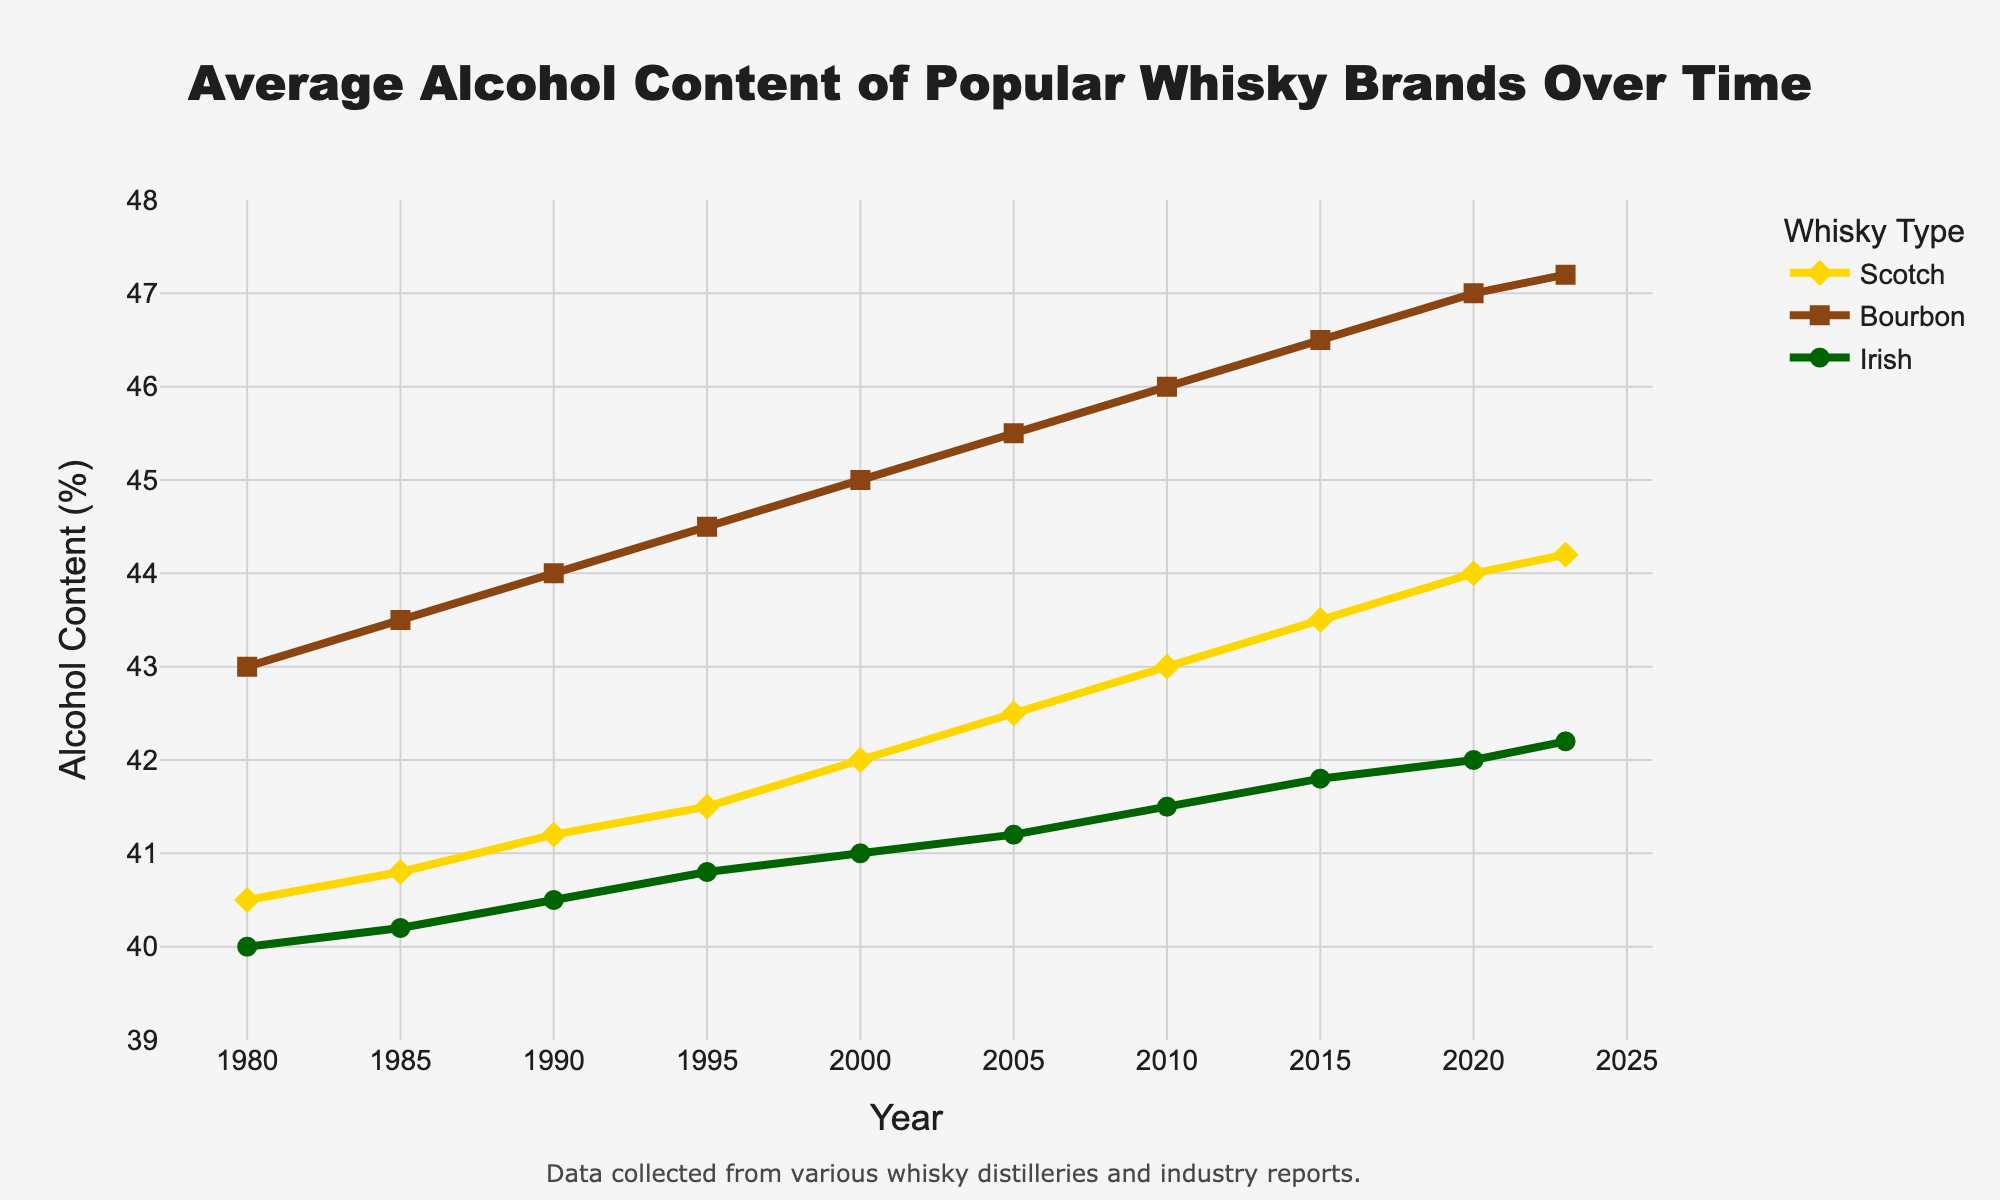What's the overall trend in the average alcohol content of Scotch from 1980 to 2023? The line for Scotch starts from 40.5% in 1980 and steadily increases to 44.2% in 2023. Therefore, the data shows a consistent upward trend in the average alcohol content of Scotch over the years.
Answer: Upward trend Between which years did Bourbon see the largest increase in average alcohol content? By visually comparing the slope of the Bourbon line, the steepest part appears between 1980 (43.0%) and 2023 (47.2%). However, for a specific interval with the steepest rise, examine the five-year intervals; the largest jump is observed between 1980-1985 (0.5%) and 1985-1990 (0.5%), consistently incrementing.
Answer: 1980 to 2023 Which whisky type had the lowest average alcohol content in 2023? At the year 2023 on the x-axis, the Irish whisky line is positioned at 42.2%, which is lower than Scotch (44.2%) and Bourbon (47.2%).
Answer: Irish What is the difference in average alcohol content between Scotch and Bourbon in 2020? In 2020, the average alcohol content for Scotch is 44.0% and for Bourbon is 47.0%. The difference between them is 47.0% - 44.0% = 3.0%.
Answer: 3.0% Which whisky type showed the least variation in the average alcohol content over the years? By visually comparing the range of the lines, the Irish whisky line is relatively flatter, starting at 40.0% in 1980 and gradually increasing to 42.2% in 2023, indicating the least variation compared to Scotch and Bourbon.
Answer: Irish How does the average alcohol content of Scotch in 1980 compare to that in 2023? The average alcohol content of Scotch in 1980 is 40.5%, while in 2023, it is 44.2%. By comparing these values, the content has increased by 44.2% - 40.5% = 3.7%.
Answer: 3.7% increase What is the average alcohol content across all whisky types in the year 2000? For 2000, Scotch is 42.0%, Bourbon is 45.0%, and Irish is 41.0%. The average alcohol content can be calculated as (42.0 + 45.0 + 41.0) / 3 = 42.67%.
Answer: 42.67% Which whisky type had the highest average alcohol content in the year 2015? In the year 2015, comparing the values: Scotch is at 43.5%, Bourbon is at 46.5%, and Irish is at 41.8%. Bourbon has the highest at 46.5%.
Answer: Bourbon What's the difference in the trend patterns between Scotch and Irish whisky from 1980 to 2023? Both Scotch and Irish whisky lines show an upward trend, indicating an increase over time. However, Scotch starts lower than Bourbon and reaches a final value of 44.2% in 2023, while Irish shows a more gradual increase, starting at 40.0% in 1980 and reaching 42.2% in 2023. Scotch experiences a larger absolute increase in alcohol content compared to Irish.
Answer: Scotch rises more sharply, Irish more gradually How much did the average alcohol content for Bourbon increase between 1990 and 2020? For Bourbon, in 1990 the average alcohol content is 44.0%, and in 2020, it is 47.0%. So, the increase is 47.0% - 44.0% = 3.0%.
Answer: 3.0% 